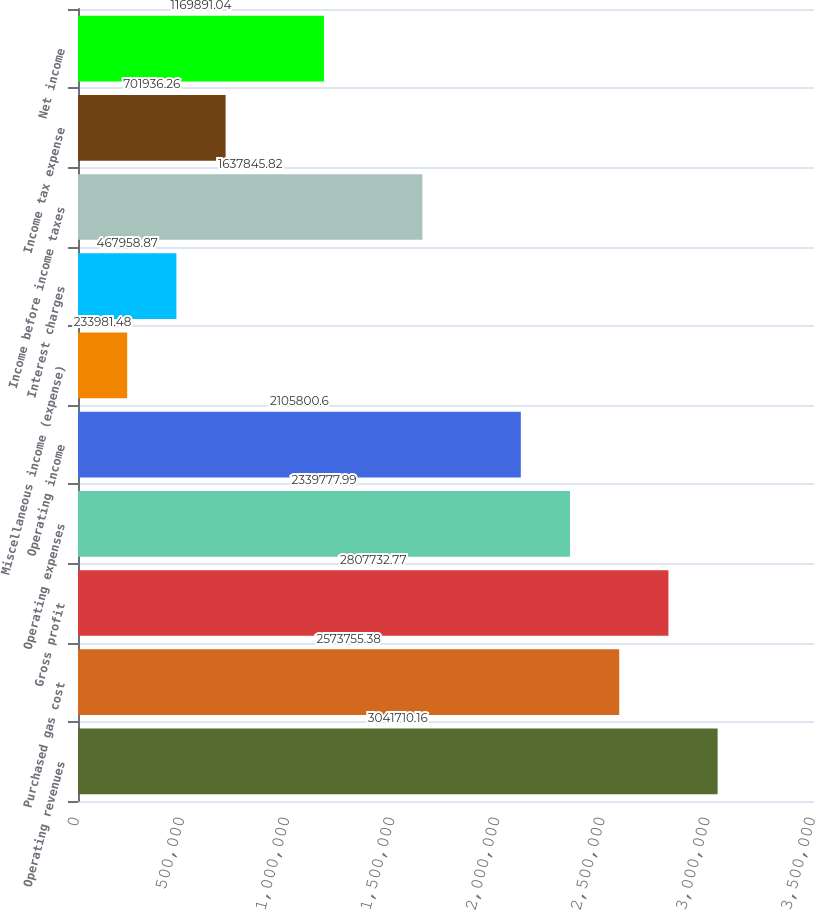Convert chart. <chart><loc_0><loc_0><loc_500><loc_500><bar_chart><fcel>Operating revenues<fcel>Purchased gas cost<fcel>Gross profit<fcel>Operating expenses<fcel>Operating income<fcel>Miscellaneous income (expense)<fcel>Interest charges<fcel>Income before income taxes<fcel>Income tax expense<fcel>Net income<nl><fcel>3.04171e+06<fcel>2.57376e+06<fcel>2.80773e+06<fcel>2.33978e+06<fcel>2.1058e+06<fcel>233981<fcel>467959<fcel>1.63785e+06<fcel>701936<fcel>1.16989e+06<nl></chart> 